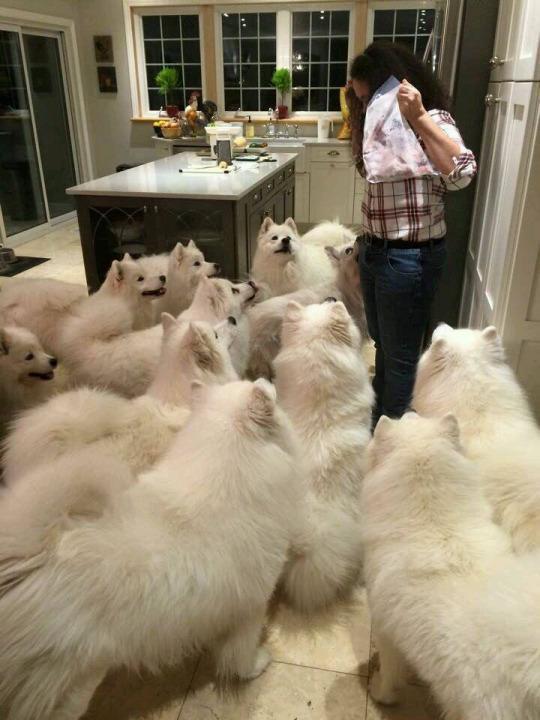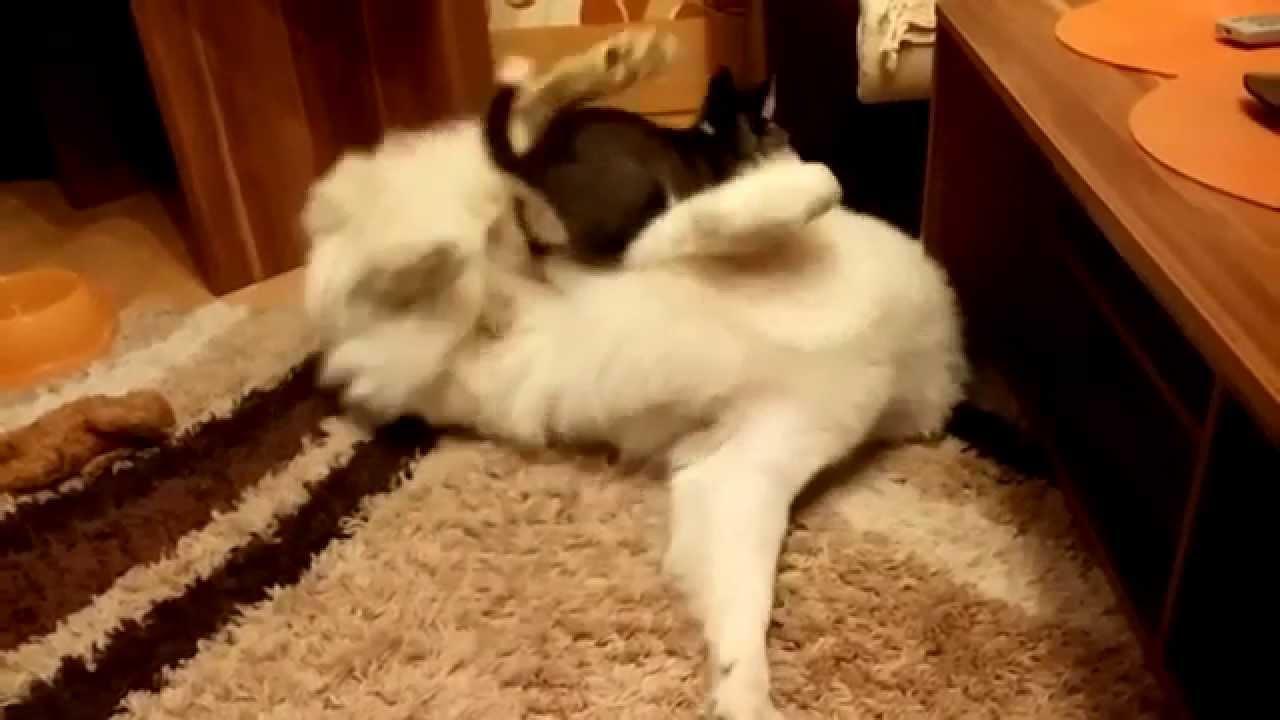The first image is the image on the left, the second image is the image on the right. Analyze the images presented: Is the assertion "A person wearing jeans is next to multiple dogs in one image." valid? Answer yes or no. Yes. The first image is the image on the left, the second image is the image on the right. Examine the images to the left and right. Is the description "In one of the images there is a small black dog on top of a big white dog that is laying on the floor." accurate? Answer yes or no. Yes. 